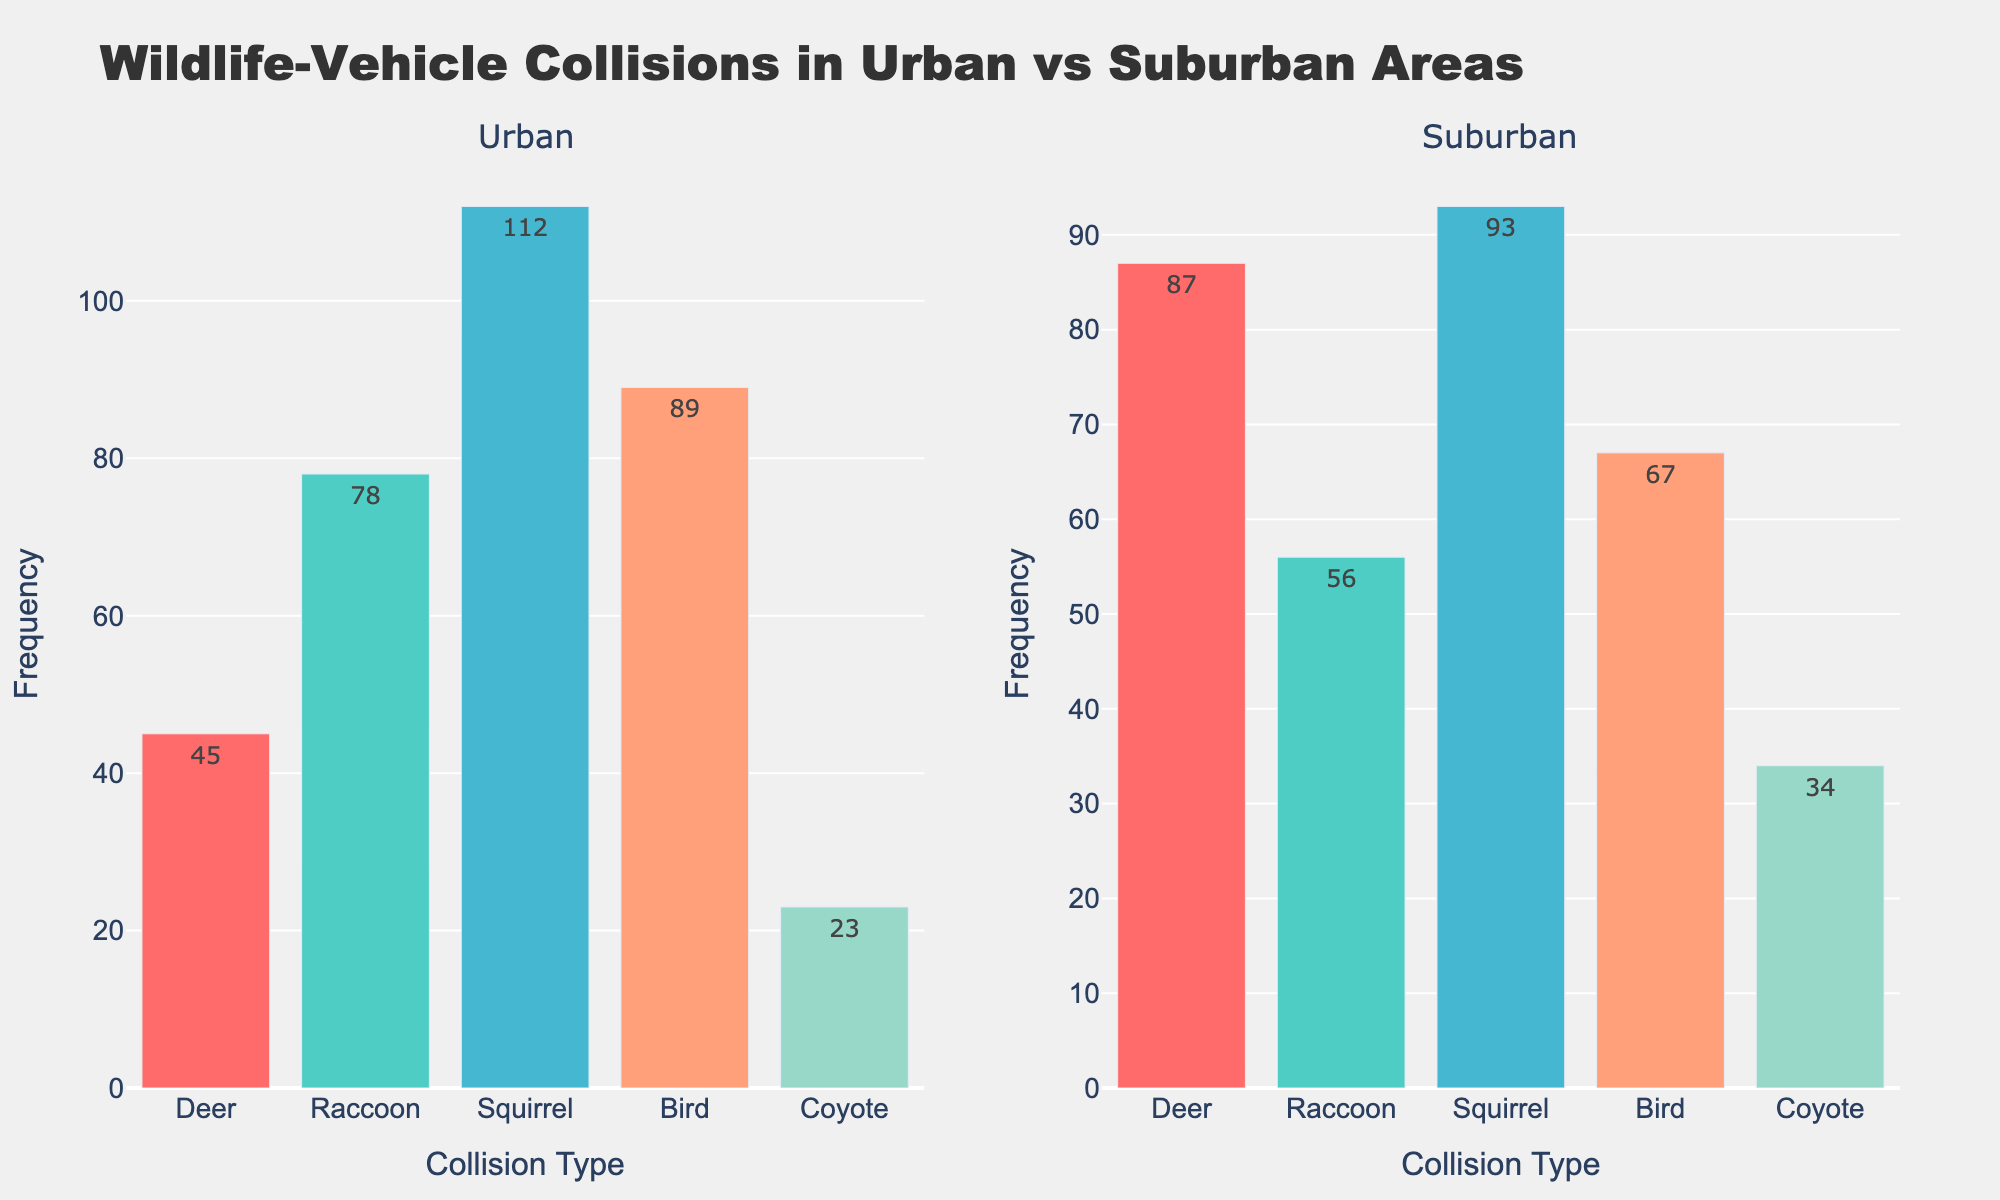What is the title of the figure? The title of the figure is located at the top center and usually provides a summary of what the graph is about. Here, it is "Wildlife-Vehicle Collisions in Urban vs Suburban Areas".
Answer: Wildlife-Vehicle Collisions in Urban vs Suburban Areas Which animal has the highest frequency of collisions in urban areas? From the urban subplot, you notice the bar for "Squirrel" is the tallest among all animals.
Answer: Squirrel How many total wildlife-vehicle collisions occurred in urban areas? Total collisions in urban areas can be calculated by summing the frequencies of each animal in the urban subplot: 45 (Deer) + 78 (Raccoon) + 112 (Squirrel) + 89 (Bird) + 23 (Coyote) = 347.
Answer: 347 Which area, urban or suburban, has a higher frequency of deer collisions? By comparing the "Deer" bars in both subplots, you see the bar in suburban areas is taller than the one in urban areas. Thus, suburban areas have a higher frequency.
Answer: Suburban How does the frequency of coyote collisions in suburban areas compare to urban areas? The frequency for coyotes in suburban areas (34) is higher than in urban areas (23).
Answer: Suburban areas have a higher frequency What is the difference in frequency of squirrel collisions between urban and suburban areas? Calculation involves subtracting the frequency of suburban squirrel collisions (93) from the urban squirrel collisions (112): 112 - 93 = 19.
Answer: 19 Which area has fewer bird collisions, urban or suburban? The height of the "Bird" bar in urban areas is compared to that in suburban areas. The urban bar (89) is taller, so suburban has fewer (67).
Answer: Suburban What is the average frequency of wildlife collisions across all animals in suburban areas? The average is calculated by summing the frequencies for suburban (87 + 56 + 93 + 67 + 34 = 337) and dividing by the number of animals (5), giving 337/5 = 67.4.
Answer: 67.4 Which animal has the smallest frequency difference between urban and suburban areas? Calculating the absolute differences: Deer (42), Raccoon (22), Squirrel (19), Bird (22), Coyote (11); the smallest difference is for Coyote (11).
Answer: Coyote What is the combined frequency of raccoon collisions in both urban and suburban areas? Adding the frequency of raccoon collisions in urban (78) and suburban (56): 78 + 56 = 134.
Answer: 134 